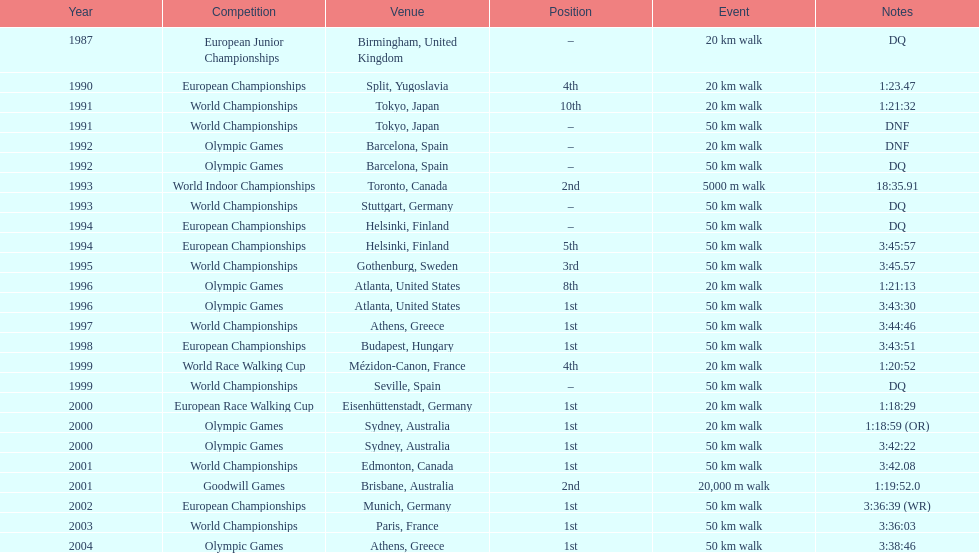In what year was korzeniowski's last competition? 2004. 